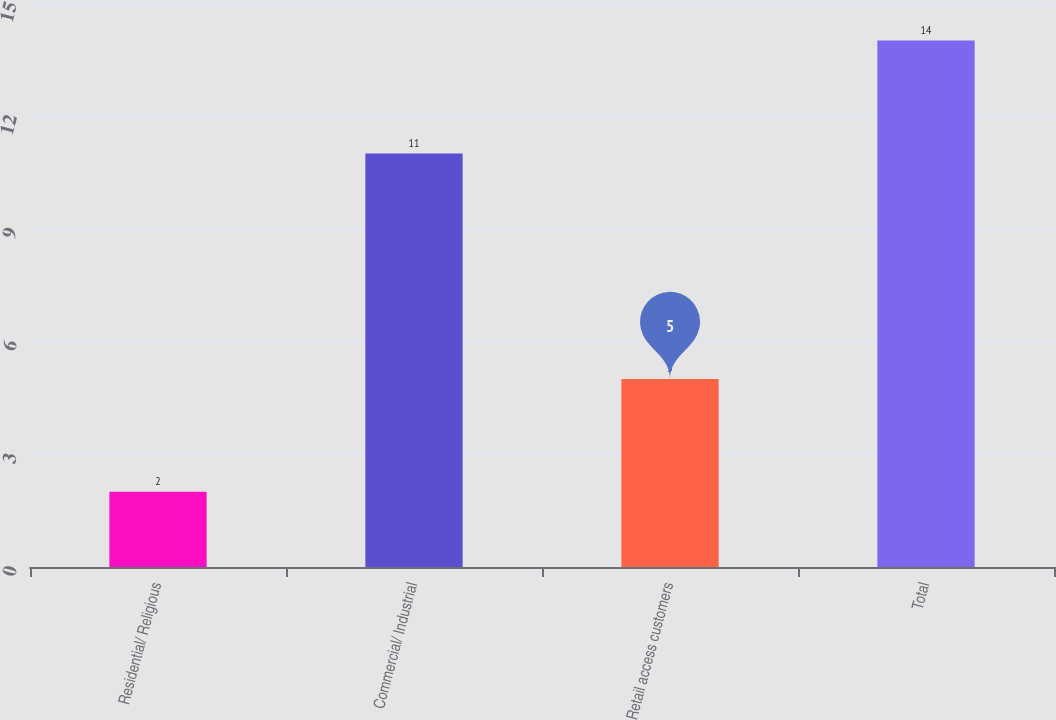Convert chart. <chart><loc_0><loc_0><loc_500><loc_500><bar_chart><fcel>Residential/ Religious<fcel>Commercial/ Industrial<fcel>Retail access customers<fcel>Total<nl><fcel>2<fcel>11<fcel>5<fcel>14<nl></chart> 